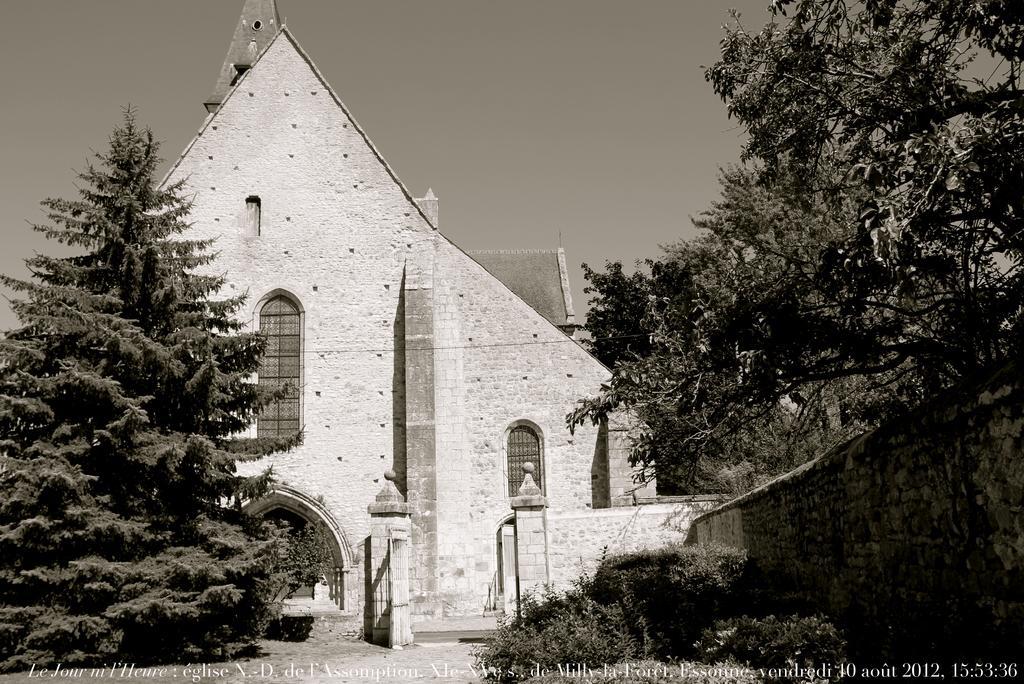Describe this image in one or two sentences. This is an black and white image. In this image, on the right side, we can see some plants, wall and trees. On the left side, we can also see some trees. In the background, we can see a building, windows. On the top, we can see a sky. 